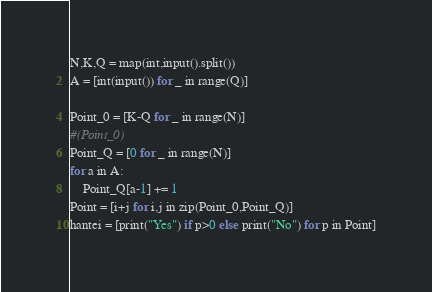<code> <loc_0><loc_0><loc_500><loc_500><_Python_>N,K,Q = map(int,input().split())
A = [int(input()) for _ in range(Q)]

Point_0 = [K-Q for _ in range(N)]
#(Point_0)
Point_Q = [0 for _ in range(N)]
for a in A:
    Point_Q[a-1] += 1
Point = [i+j for i,j in zip(Point_0,Point_Q)]
hantei = [print("Yes") if p>0 else print("No") for p in Point]</code> 